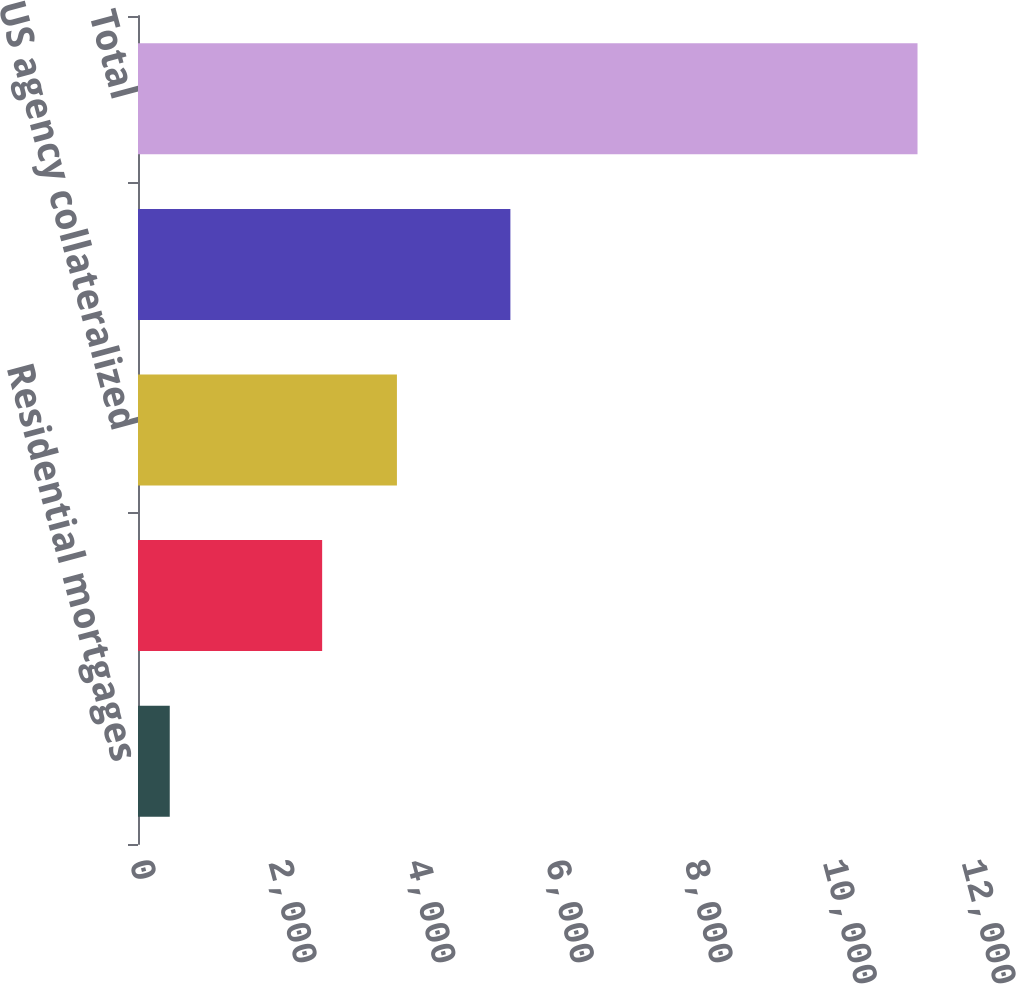Convert chart. <chart><loc_0><loc_0><loc_500><loc_500><bar_chart><fcel>Residential mortgages<fcel>Commercial mortgages<fcel>US agency collateralized<fcel>Other consumer or commercial<fcel>Total<nl><fcel>458<fcel>2656<fcel>3734.5<fcel>5371<fcel>11243<nl></chart> 